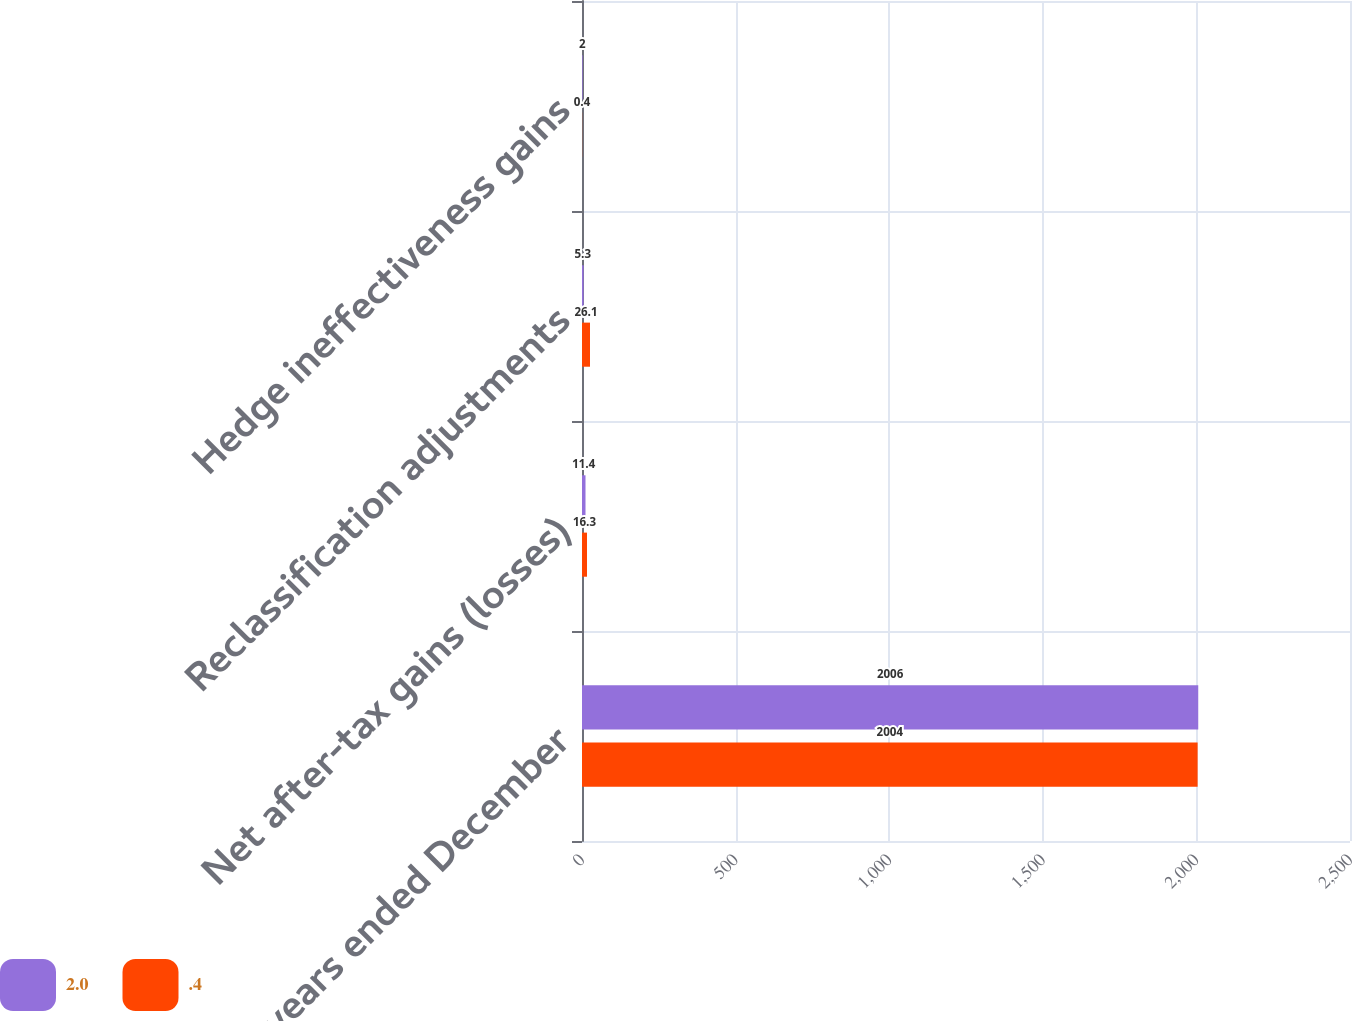Convert chart. <chart><loc_0><loc_0><loc_500><loc_500><stacked_bar_chart><ecel><fcel>For the years ended December<fcel>Net after-tax gains (losses)<fcel>Reclassification adjustments<fcel>Hedge ineffectiveness gains<nl><fcel>2<fcel>2006<fcel>11.4<fcel>5.3<fcel>2<nl><fcel>0.4<fcel>2004<fcel>16.3<fcel>26.1<fcel>0.4<nl></chart> 